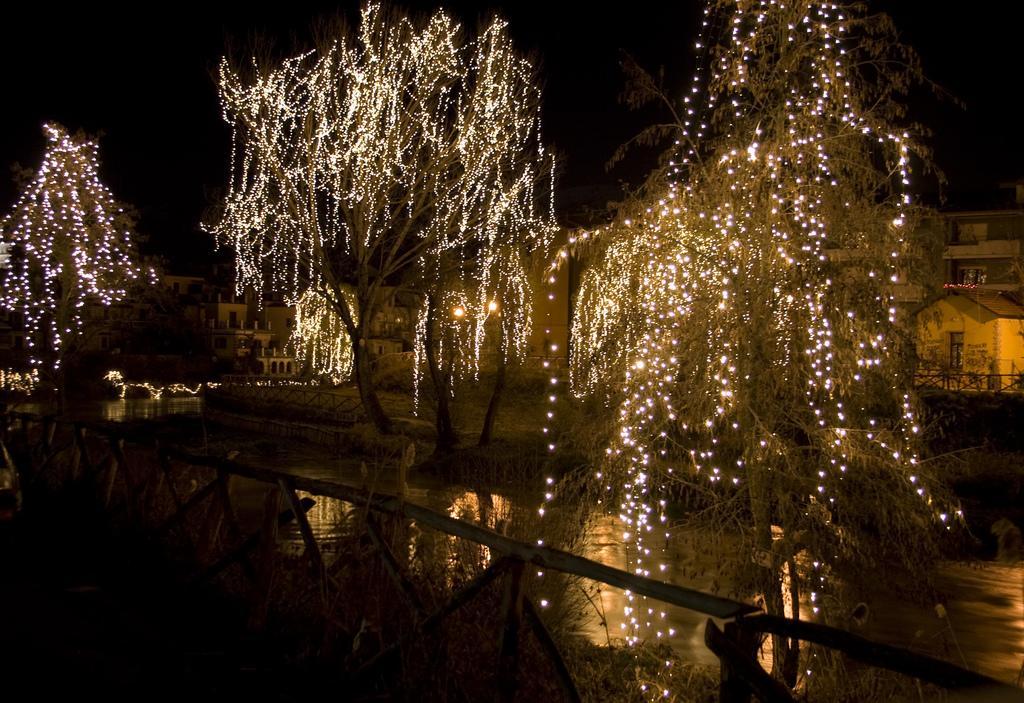In one or two sentences, can you explain what this image depicts? In this image I can see the water. In the background I can see few trees decorated with lights and I can also see few buildings and the sky is in black color. 